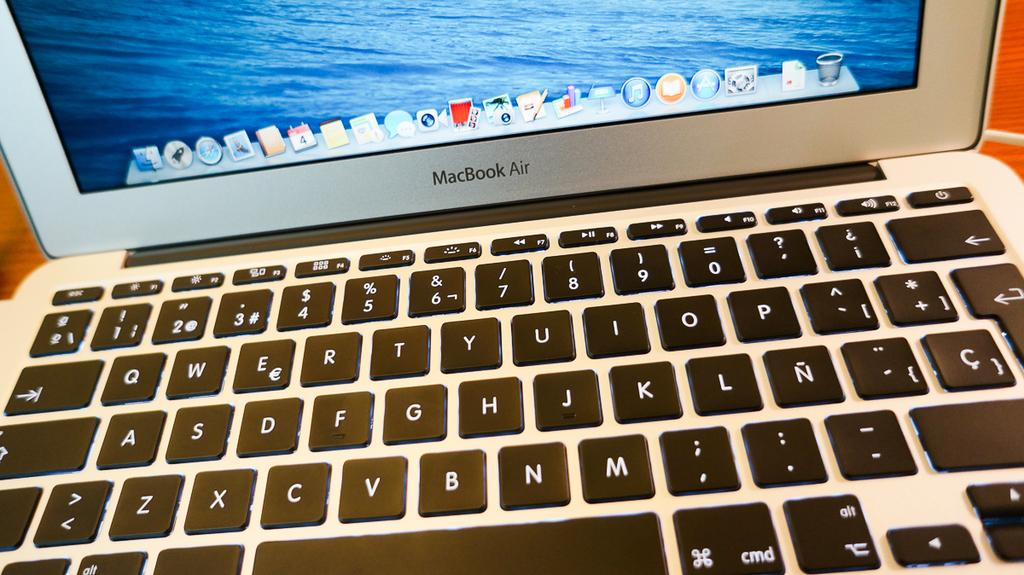<image>
Render a clear and concise summary of the photo. Macbook Air laptop with the power button on the top right. 